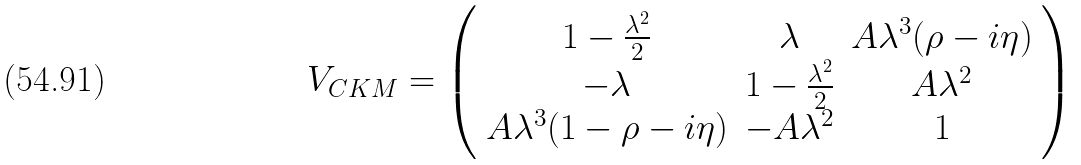<formula> <loc_0><loc_0><loc_500><loc_500>V _ { C K M } = \left ( \begin{array} { c c c } { { 1 - \frac { \lambda ^ { 2 } } { 2 } } } & { \lambda } & { { A \lambda ^ { 3 } ( \rho - i \eta ) } } \\ { - \lambda } & { { 1 - \frac { \lambda ^ { 2 } } { 2 } } } & { { A \lambda ^ { 2 } } } \\ { { A \lambda ^ { 3 } ( 1 - \rho - i \eta ) } } & { { - A \lambda ^ { 2 } } } & { 1 } \end{array} \right )</formula> 